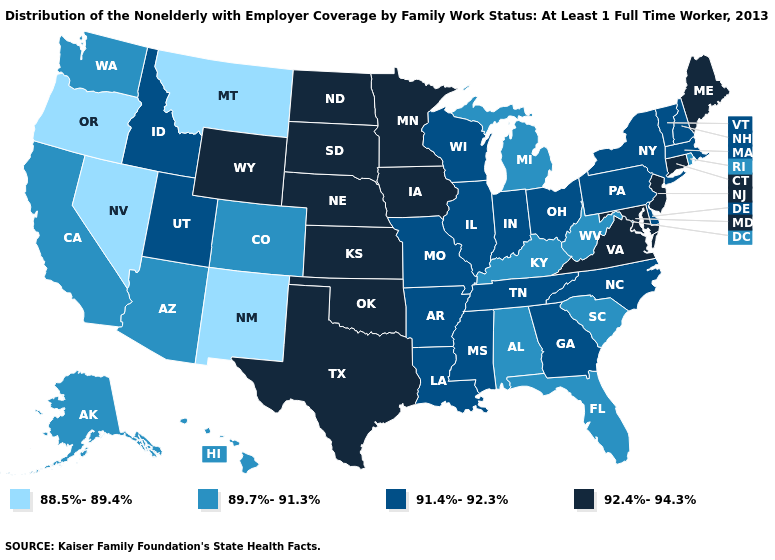Among the states that border Minnesota , which have the highest value?
Be succinct. Iowa, North Dakota, South Dakota. Name the states that have a value in the range 92.4%-94.3%?
Give a very brief answer. Connecticut, Iowa, Kansas, Maine, Maryland, Minnesota, Nebraska, New Jersey, North Dakota, Oklahoma, South Dakota, Texas, Virginia, Wyoming. Among the states that border Washington , which have the highest value?
Keep it brief. Idaho. Does Illinois have the highest value in the USA?
Answer briefly. No. What is the value of North Carolina?
Write a very short answer. 91.4%-92.3%. Which states have the lowest value in the USA?
Concise answer only. Montana, Nevada, New Mexico, Oregon. Name the states that have a value in the range 92.4%-94.3%?
Short answer required. Connecticut, Iowa, Kansas, Maine, Maryland, Minnesota, Nebraska, New Jersey, North Dakota, Oklahoma, South Dakota, Texas, Virginia, Wyoming. Name the states that have a value in the range 89.7%-91.3%?
Quick response, please. Alabama, Alaska, Arizona, California, Colorado, Florida, Hawaii, Kentucky, Michigan, Rhode Island, South Carolina, Washington, West Virginia. Does the map have missing data?
Be succinct. No. Name the states that have a value in the range 89.7%-91.3%?
Write a very short answer. Alabama, Alaska, Arizona, California, Colorado, Florida, Hawaii, Kentucky, Michigan, Rhode Island, South Carolina, Washington, West Virginia. Name the states that have a value in the range 88.5%-89.4%?
Be succinct. Montana, Nevada, New Mexico, Oregon. What is the value of Maine?
Keep it brief. 92.4%-94.3%. Which states have the lowest value in the USA?
Short answer required. Montana, Nevada, New Mexico, Oregon. Name the states that have a value in the range 92.4%-94.3%?
Concise answer only. Connecticut, Iowa, Kansas, Maine, Maryland, Minnesota, Nebraska, New Jersey, North Dakota, Oklahoma, South Dakota, Texas, Virginia, Wyoming. What is the value of Oklahoma?
Give a very brief answer. 92.4%-94.3%. 